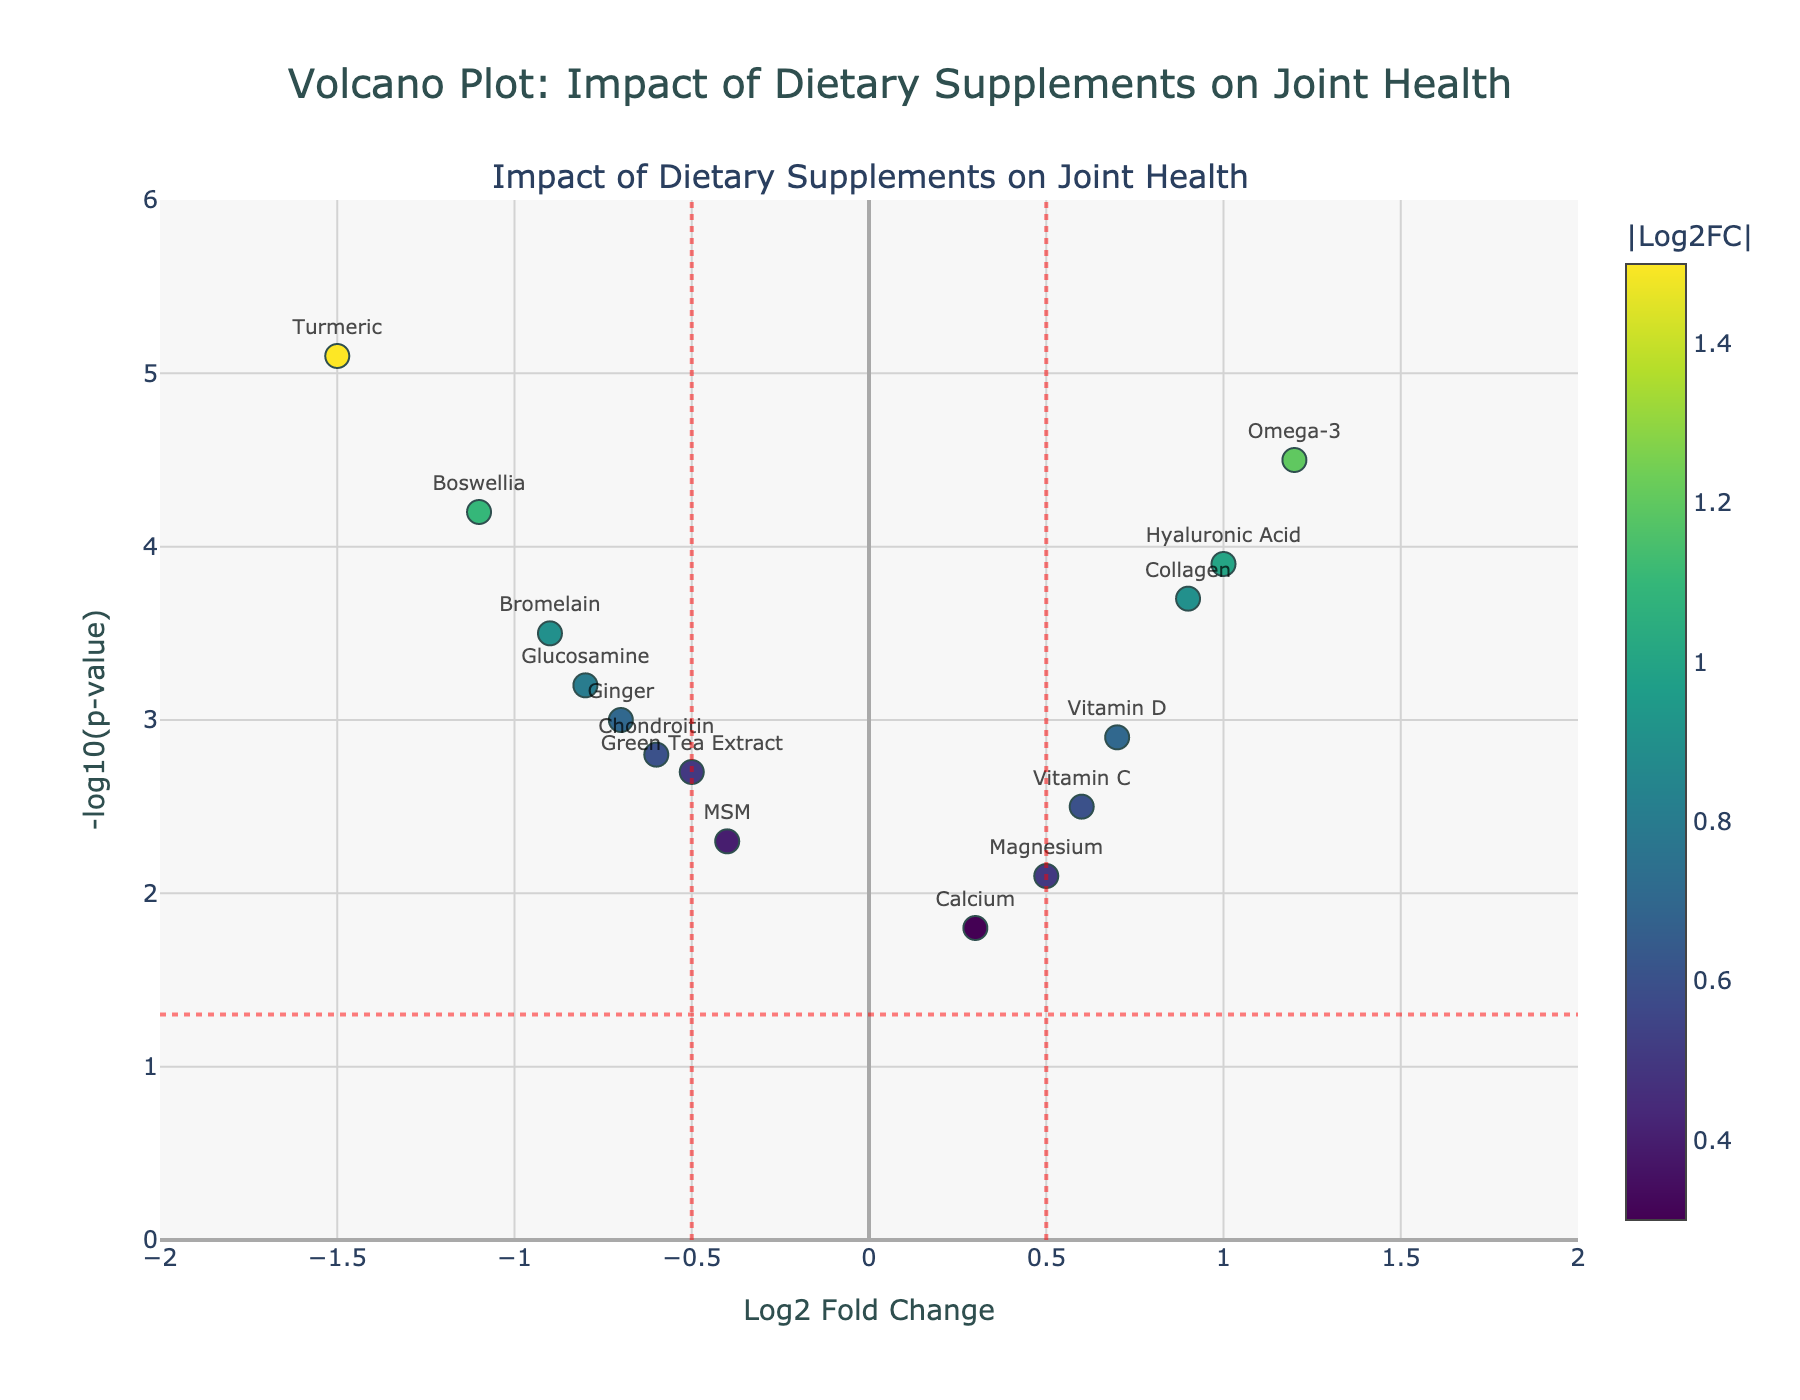Which dietary supplement has the highest -log10(p-value)? To determine which supplement has the highest -log10(p-value), look for the one with the highest point on the y-axis. In this case, the highest point on the y-axis corresponds to Turmeric.
Answer: Turmeric How many dietary supplements have a Log2 Fold Change greater than 0.5? To find out how many supplements have a Log2 Fold Change greater than 0.5, check the number of points to the right of the vertical threshold line at x=0.5. These points are Omega-3, Collagen, Vitamin D, and Hyaluronic Acid.
Answer: 4 What is the Log2 Fold Change of Ginger? Identify the point labeled Ginger in the plot and then read its position on the x-axis. The position corresponding to Ginger on the x-axis is -0.7.
Answer: -0.7 Which supplement shows a statistically significant change with the most negative Log2Fold Change? A statistically significant change is indicated by points above the horizontal threshold line on the y-axis (-log10(p-value) = 1.3). For the most negative Log2 Fold Change, look leftmost among these points. Turmeric has the lowest Log2 Fold Change at -1.5.
Answer: Turmeric What supplements fall within the threshold area set by both the Log2 Fold Change and p-value? Points that fall inside the thresholds are within -0.5 < Log2FoldChange < 0.5 and below the horizontal threshold line (y < 1.3).
Answer: Calcium and Magnesium Which supplements have a Negative Log10(p-value) greater than 4? To find the supplements with a -log10(p-value) greater than 4, check points above y=4. The points are Omega-3, Turmeric, and Boswellia.
Answer: Omega-3, Turmeric, Boswellia Comparing Collagen and MSM, which one has a higher -log10(p-value)? To compare these two supplements, find their positions on the y-axis. Collagen is at 3.7, and MSM is at 2.3.
Answer: Collagen What is the fold change of Vitamin C? Identify the Vitamin C data point in the plot and read its position on the x-axis. The Log2FoldChange for Vitamin C is 0.6.
Answer: 0.6 Which supplement is closest to the Log2 Fold Change threshold of 0.5? Check the points near the vertical line at x=0.5 and find the closest one. Vitamin D is the closest with a Log2 Fold Change of 0.7.
Answer: Vitamin D 